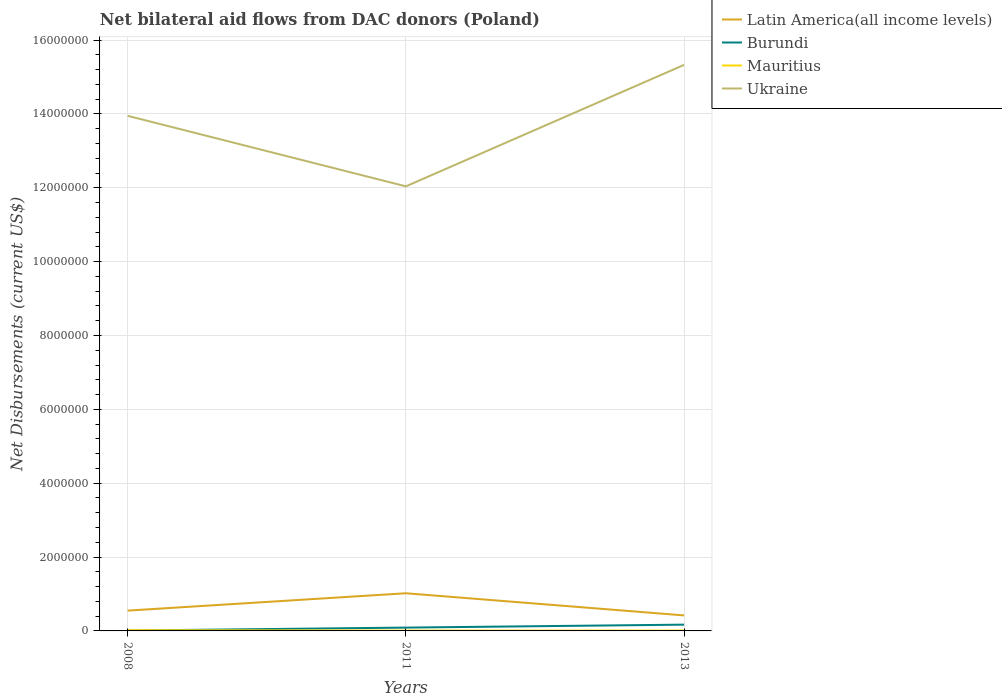How many different coloured lines are there?
Your answer should be very brief. 4. Does the line corresponding to Ukraine intersect with the line corresponding to Mauritius?
Provide a short and direct response. No. Is the number of lines equal to the number of legend labels?
Offer a terse response. Yes. Across all years, what is the maximum net bilateral aid flows in Mauritius?
Offer a terse response. 10000. In which year was the net bilateral aid flows in Ukraine maximum?
Ensure brevity in your answer.  2011. What is the total net bilateral aid flows in Mauritius in the graph?
Ensure brevity in your answer.  10000. What is the difference between the highest and the second highest net bilateral aid flows in Mauritius?
Offer a terse response. 10000. What is the difference between the highest and the lowest net bilateral aid flows in Burundi?
Your answer should be compact. 1. Is the net bilateral aid flows in Mauritius strictly greater than the net bilateral aid flows in Ukraine over the years?
Your answer should be very brief. Yes. How many lines are there?
Provide a succinct answer. 4. What is the difference between two consecutive major ticks on the Y-axis?
Your answer should be compact. 2.00e+06. Are the values on the major ticks of Y-axis written in scientific E-notation?
Your answer should be very brief. No. Does the graph contain any zero values?
Keep it short and to the point. No. Does the graph contain grids?
Offer a terse response. Yes. Where does the legend appear in the graph?
Offer a terse response. Top right. How many legend labels are there?
Offer a terse response. 4. What is the title of the graph?
Give a very brief answer. Net bilateral aid flows from DAC donors (Poland). What is the label or title of the X-axis?
Keep it short and to the point. Years. What is the label or title of the Y-axis?
Give a very brief answer. Net Disbursements (current US$). What is the Net Disbursements (current US$) in Latin America(all income levels) in 2008?
Your response must be concise. 5.50e+05. What is the Net Disbursements (current US$) of Burundi in 2008?
Keep it short and to the point. 10000. What is the Net Disbursements (current US$) in Mauritius in 2008?
Provide a short and direct response. 2.00e+04. What is the Net Disbursements (current US$) in Ukraine in 2008?
Keep it short and to the point. 1.40e+07. What is the Net Disbursements (current US$) in Latin America(all income levels) in 2011?
Provide a succinct answer. 1.02e+06. What is the Net Disbursements (current US$) of Burundi in 2011?
Keep it short and to the point. 9.00e+04. What is the Net Disbursements (current US$) in Mauritius in 2011?
Your response must be concise. 10000. What is the Net Disbursements (current US$) of Ukraine in 2011?
Keep it short and to the point. 1.20e+07. What is the Net Disbursements (current US$) in Mauritius in 2013?
Ensure brevity in your answer.  10000. What is the Net Disbursements (current US$) in Ukraine in 2013?
Your answer should be very brief. 1.53e+07. Across all years, what is the maximum Net Disbursements (current US$) in Latin America(all income levels)?
Keep it short and to the point. 1.02e+06. Across all years, what is the maximum Net Disbursements (current US$) in Mauritius?
Give a very brief answer. 2.00e+04. Across all years, what is the maximum Net Disbursements (current US$) of Ukraine?
Your answer should be compact. 1.53e+07. Across all years, what is the minimum Net Disbursements (current US$) of Latin America(all income levels)?
Keep it short and to the point. 4.20e+05. Across all years, what is the minimum Net Disbursements (current US$) of Mauritius?
Make the answer very short. 10000. Across all years, what is the minimum Net Disbursements (current US$) in Ukraine?
Make the answer very short. 1.20e+07. What is the total Net Disbursements (current US$) of Latin America(all income levels) in the graph?
Give a very brief answer. 1.99e+06. What is the total Net Disbursements (current US$) of Mauritius in the graph?
Ensure brevity in your answer.  4.00e+04. What is the total Net Disbursements (current US$) of Ukraine in the graph?
Give a very brief answer. 4.13e+07. What is the difference between the Net Disbursements (current US$) in Latin America(all income levels) in 2008 and that in 2011?
Your response must be concise. -4.70e+05. What is the difference between the Net Disbursements (current US$) of Burundi in 2008 and that in 2011?
Provide a short and direct response. -8.00e+04. What is the difference between the Net Disbursements (current US$) of Ukraine in 2008 and that in 2011?
Give a very brief answer. 1.91e+06. What is the difference between the Net Disbursements (current US$) in Latin America(all income levels) in 2008 and that in 2013?
Keep it short and to the point. 1.30e+05. What is the difference between the Net Disbursements (current US$) in Mauritius in 2008 and that in 2013?
Provide a short and direct response. 10000. What is the difference between the Net Disbursements (current US$) in Ukraine in 2008 and that in 2013?
Your answer should be very brief. -1.38e+06. What is the difference between the Net Disbursements (current US$) of Burundi in 2011 and that in 2013?
Offer a terse response. -8.00e+04. What is the difference between the Net Disbursements (current US$) in Ukraine in 2011 and that in 2013?
Give a very brief answer. -3.29e+06. What is the difference between the Net Disbursements (current US$) in Latin America(all income levels) in 2008 and the Net Disbursements (current US$) in Mauritius in 2011?
Offer a terse response. 5.40e+05. What is the difference between the Net Disbursements (current US$) in Latin America(all income levels) in 2008 and the Net Disbursements (current US$) in Ukraine in 2011?
Ensure brevity in your answer.  -1.15e+07. What is the difference between the Net Disbursements (current US$) in Burundi in 2008 and the Net Disbursements (current US$) in Ukraine in 2011?
Offer a terse response. -1.20e+07. What is the difference between the Net Disbursements (current US$) of Mauritius in 2008 and the Net Disbursements (current US$) of Ukraine in 2011?
Give a very brief answer. -1.20e+07. What is the difference between the Net Disbursements (current US$) of Latin America(all income levels) in 2008 and the Net Disbursements (current US$) of Mauritius in 2013?
Give a very brief answer. 5.40e+05. What is the difference between the Net Disbursements (current US$) of Latin America(all income levels) in 2008 and the Net Disbursements (current US$) of Ukraine in 2013?
Your answer should be compact. -1.48e+07. What is the difference between the Net Disbursements (current US$) of Burundi in 2008 and the Net Disbursements (current US$) of Ukraine in 2013?
Provide a succinct answer. -1.53e+07. What is the difference between the Net Disbursements (current US$) of Mauritius in 2008 and the Net Disbursements (current US$) of Ukraine in 2013?
Offer a very short reply. -1.53e+07. What is the difference between the Net Disbursements (current US$) of Latin America(all income levels) in 2011 and the Net Disbursements (current US$) of Burundi in 2013?
Your answer should be very brief. 8.50e+05. What is the difference between the Net Disbursements (current US$) of Latin America(all income levels) in 2011 and the Net Disbursements (current US$) of Mauritius in 2013?
Make the answer very short. 1.01e+06. What is the difference between the Net Disbursements (current US$) in Latin America(all income levels) in 2011 and the Net Disbursements (current US$) in Ukraine in 2013?
Your answer should be very brief. -1.43e+07. What is the difference between the Net Disbursements (current US$) in Burundi in 2011 and the Net Disbursements (current US$) in Mauritius in 2013?
Your answer should be very brief. 8.00e+04. What is the difference between the Net Disbursements (current US$) in Burundi in 2011 and the Net Disbursements (current US$) in Ukraine in 2013?
Keep it short and to the point. -1.52e+07. What is the difference between the Net Disbursements (current US$) in Mauritius in 2011 and the Net Disbursements (current US$) in Ukraine in 2013?
Keep it short and to the point. -1.53e+07. What is the average Net Disbursements (current US$) of Latin America(all income levels) per year?
Make the answer very short. 6.63e+05. What is the average Net Disbursements (current US$) in Burundi per year?
Make the answer very short. 9.00e+04. What is the average Net Disbursements (current US$) of Mauritius per year?
Ensure brevity in your answer.  1.33e+04. What is the average Net Disbursements (current US$) of Ukraine per year?
Provide a short and direct response. 1.38e+07. In the year 2008, what is the difference between the Net Disbursements (current US$) in Latin America(all income levels) and Net Disbursements (current US$) in Burundi?
Keep it short and to the point. 5.40e+05. In the year 2008, what is the difference between the Net Disbursements (current US$) of Latin America(all income levels) and Net Disbursements (current US$) of Mauritius?
Ensure brevity in your answer.  5.30e+05. In the year 2008, what is the difference between the Net Disbursements (current US$) of Latin America(all income levels) and Net Disbursements (current US$) of Ukraine?
Your answer should be compact. -1.34e+07. In the year 2008, what is the difference between the Net Disbursements (current US$) of Burundi and Net Disbursements (current US$) of Ukraine?
Your response must be concise. -1.39e+07. In the year 2008, what is the difference between the Net Disbursements (current US$) in Mauritius and Net Disbursements (current US$) in Ukraine?
Your answer should be very brief. -1.39e+07. In the year 2011, what is the difference between the Net Disbursements (current US$) of Latin America(all income levels) and Net Disbursements (current US$) of Burundi?
Make the answer very short. 9.30e+05. In the year 2011, what is the difference between the Net Disbursements (current US$) in Latin America(all income levels) and Net Disbursements (current US$) in Mauritius?
Provide a short and direct response. 1.01e+06. In the year 2011, what is the difference between the Net Disbursements (current US$) in Latin America(all income levels) and Net Disbursements (current US$) in Ukraine?
Your answer should be very brief. -1.10e+07. In the year 2011, what is the difference between the Net Disbursements (current US$) of Burundi and Net Disbursements (current US$) of Ukraine?
Your response must be concise. -1.20e+07. In the year 2011, what is the difference between the Net Disbursements (current US$) in Mauritius and Net Disbursements (current US$) in Ukraine?
Your response must be concise. -1.20e+07. In the year 2013, what is the difference between the Net Disbursements (current US$) in Latin America(all income levels) and Net Disbursements (current US$) in Burundi?
Offer a terse response. 2.50e+05. In the year 2013, what is the difference between the Net Disbursements (current US$) of Latin America(all income levels) and Net Disbursements (current US$) of Mauritius?
Give a very brief answer. 4.10e+05. In the year 2013, what is the difference between the Net Disbursements (current US$) in Latin America(all income levels) and Net Disbursements (current US$) in Ukraine?
Provide a short and direct response. -1.49e+07. In the year 2013, what is the difference between the Net Disbursements (current US$) in Burundi and Net Disbursements (current US$) in Mauritius?
Your response must be concise. 1.60e+05. In the year 2013, what is the difference between the Net Disbursements (current US$) in Burundi and Net Disbursements (current US$) in Ukraine?
Provide a succinct answer. -1.52e+07. In the year 2013, what is the difference between the Net Disbursements (current US$) of Mauritius and Net Disbursements (current US$) of Ukraine?
Your response must be concise. -1.53e+07. What is the ratio of the Net Disbursements (current US$) in Latin America(all income levels) in 2008 to that in 2011?
Give a very brief answer. 0.54. What is the ratio of the Net Disbursements (current US$) of Burundi in 2008 to that in 2011?
Give a very brief answer. 0.11. What is the ratio of the Net Disbursements (current US$) of Mauritius in 2008 to that in 2011?
Offer a very short reply. 2. What is the ratio of the Net Disbursements (current US$) in Ukraine in 2008 to that in 2011?
Offer a terse response. 1.16. What is the ratio of the Net Disbursements (current US$) in Latin America(all income levels) in 2008 to that in 2013?
Your answer should be compact. 1.31. What is the ratio of the Net Disbursements (current US$) of Burundi in 2008 to that in 2013?
Your answer should be very brief. 0.06. What is the ratio of the Net Disbursements (current US$) of Ukraine in 2008 to that in 2013?
Make the answer very short. 0.91. What is the ratio of the Net Disbursements (current US$) in Latin America(all income levels) in 2011 to that in 2013?
Provide a short and direct response. 2.43. What is the ratio of the Net Disbursements (current US$) of Burundi in 2011 to that in 2013?
Your answer should be very brief. 0.53. What is the ratio of the Net Disbursements (current US$) in Ukraine in 2011 to that in 2013?
Your response must be concise. 0.79. What is the difference between the highest and the second highest Net Disbursements (current US$) of Mauritius?
Offer a terse response. 10000. What is the difference between the highest and the second highest Net Disbursements (current US$) in Ukraine?
Your answer should be compact. 1.38e+06. What is the difference between the highest and the lowest Net Disbursements (current US$) of Latin America(all income levels)?
Provide a short and direct response. 6.00e+05. What is the difference between the highest and the lowest Net Disbursements (current US$) in Mauritius?
Your answer should be compact. 10000. What is the difference between the highest and the lowest Net Disbursements (current US$) of Ukraine?
Offer a terse response. 3.29e+06. 